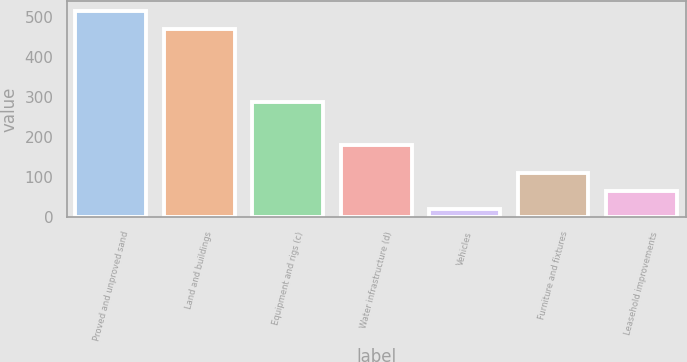Convert chart to OTSL. <chart><loc_0><loc_0><loc_500><loc_500><bar_chart><fcel>Proved and unproved sand<fcel>Land and buildings<fcel>Equipment and rigs (c)<fcel>Water infrastructure (d)<fcel>Vehicles<fcel>Furniture and fixtures<fcel>Leasehold improvements<nl><fcel>513.2<fcel>468<fcel>287<fcel>180<fcel>21<fcel>111.4<fcel>66.2<nl></chart> 